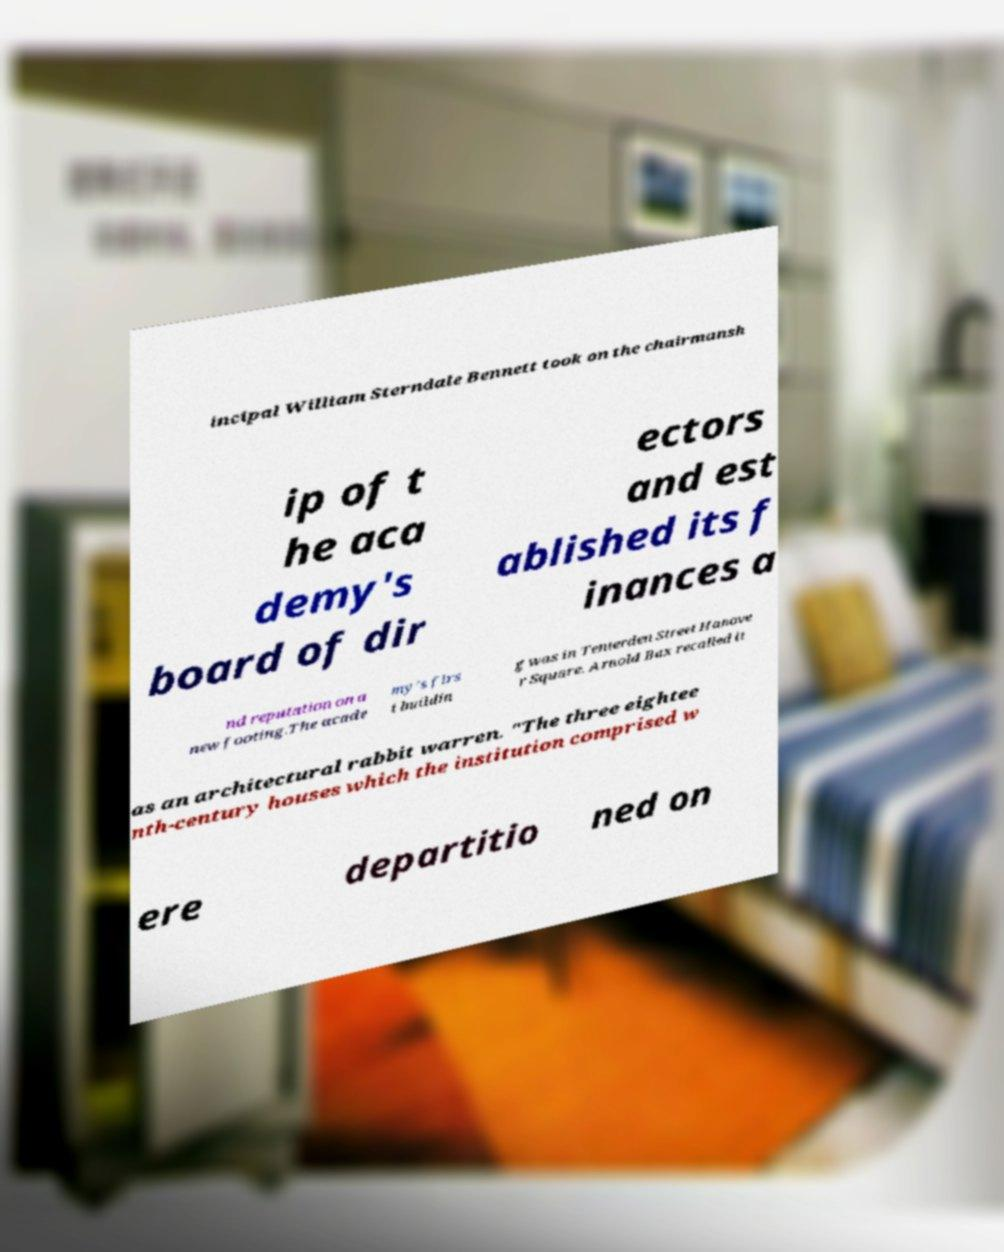Can you accurately transcribe the text from the provided image for me? incipal William Sterndale Bennett took on the chairmansh ip of t he aca demy's board of dir ectors and est ablished its f inances a nd reputation on a new footing.The acade my's firs t buildin g was in Tenterden Street Hanove r Square. Arnold Bax recalled it as an architectural rabbit warren. "The three eightee nth-century houses which the institution comprised w ere departitio ned on 